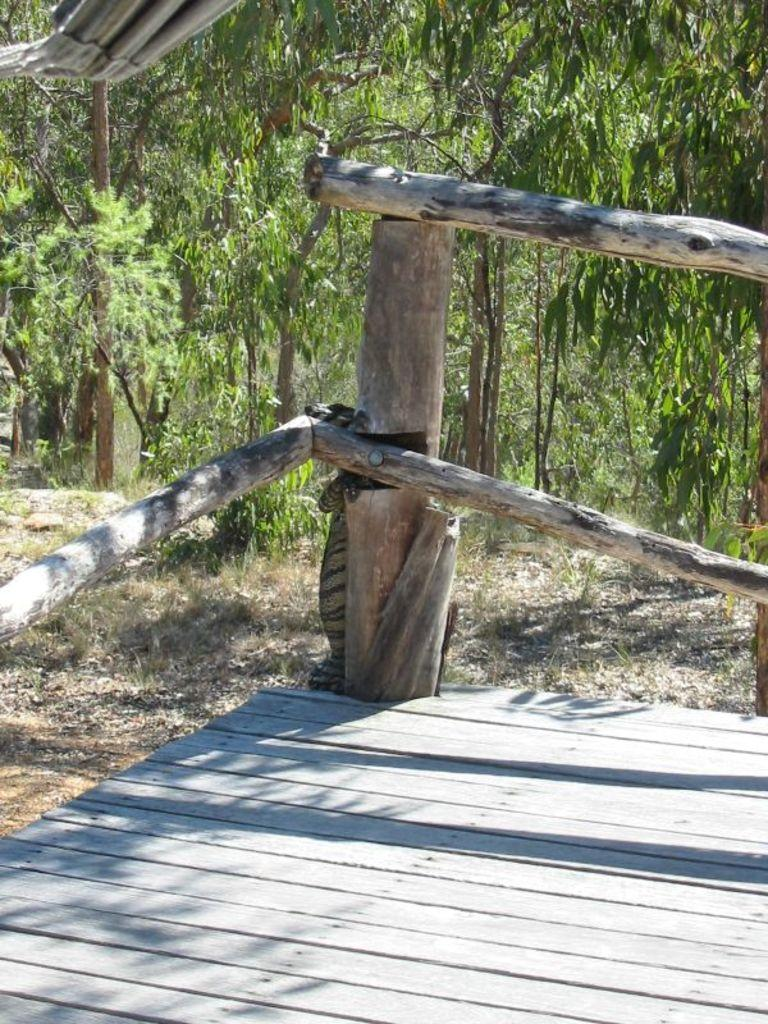What type of surface is at the bottom of the image? There is a wooden stage at the bottom of the image. What objects are on the wooden stage? There are sticks on the stage. What can be seen in the background of the image? There is grass and trees visible in the background of the image. What type of breakfast is being served on the wooden stage? There is no breakfast present in the image; it features a wooden stage with sticks on it. How are the sticks balanced on the wooden stage? The question of balance is not relevant to the image, as the sticks are simply resting on the wooden stage. 